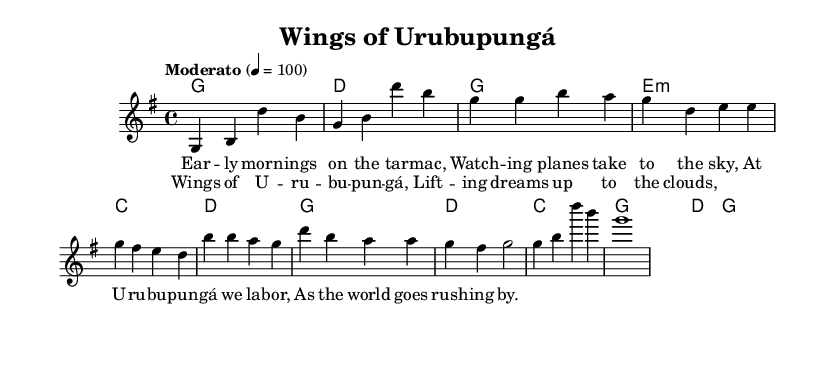What is the key signature of this music? The key signature is G major, represented by one sharp (F#). This can be identified at the beginning of the sheet music where the key signature is indicated.
Answer: G major What is the time signature of the piece? The time signature is 4/4, which denotes four beats in each measure, indicated at the start of the sheet music.
Answer: 4/4 What is the tempo marking for this piece? The tempo marking is "Moderato," which means moderately, and it is specified at the beginning along with the metronome marking of quarter note equals 100.
Answer: Moderato How many measures are in the chorus section? The chorus section consists of four measures; this can be counted from the music notation of the chorus part, which shows four distinct bars.
Answer: 4 Which chord follows the second line of the verse? The chord that follows the second line of the verse is E minor, which can be determined by looking at the chord symbols that align with the corresponding lyrics.
Answer: E minor What is the main theme depicted in the lyrics of this song? The main theme in the lyrics of the song reflects the daily lives of airport workers, particularly focusing on their experiences and observations at the airport. This can be inferred from the phrases used in the lyrics that describe work at the airport.
Answer: Daily lives of airport workers What do the lyrics of the chorus emphasize? The lyrics of the chorus emphasize the uplifting aspect of their work, as indicated by the phrase "Wings of Urubupungá, lifting dreams up to the clouds", highlighting the hope and aspirations tied to their jobs.
Answer: Uplifting dreams 